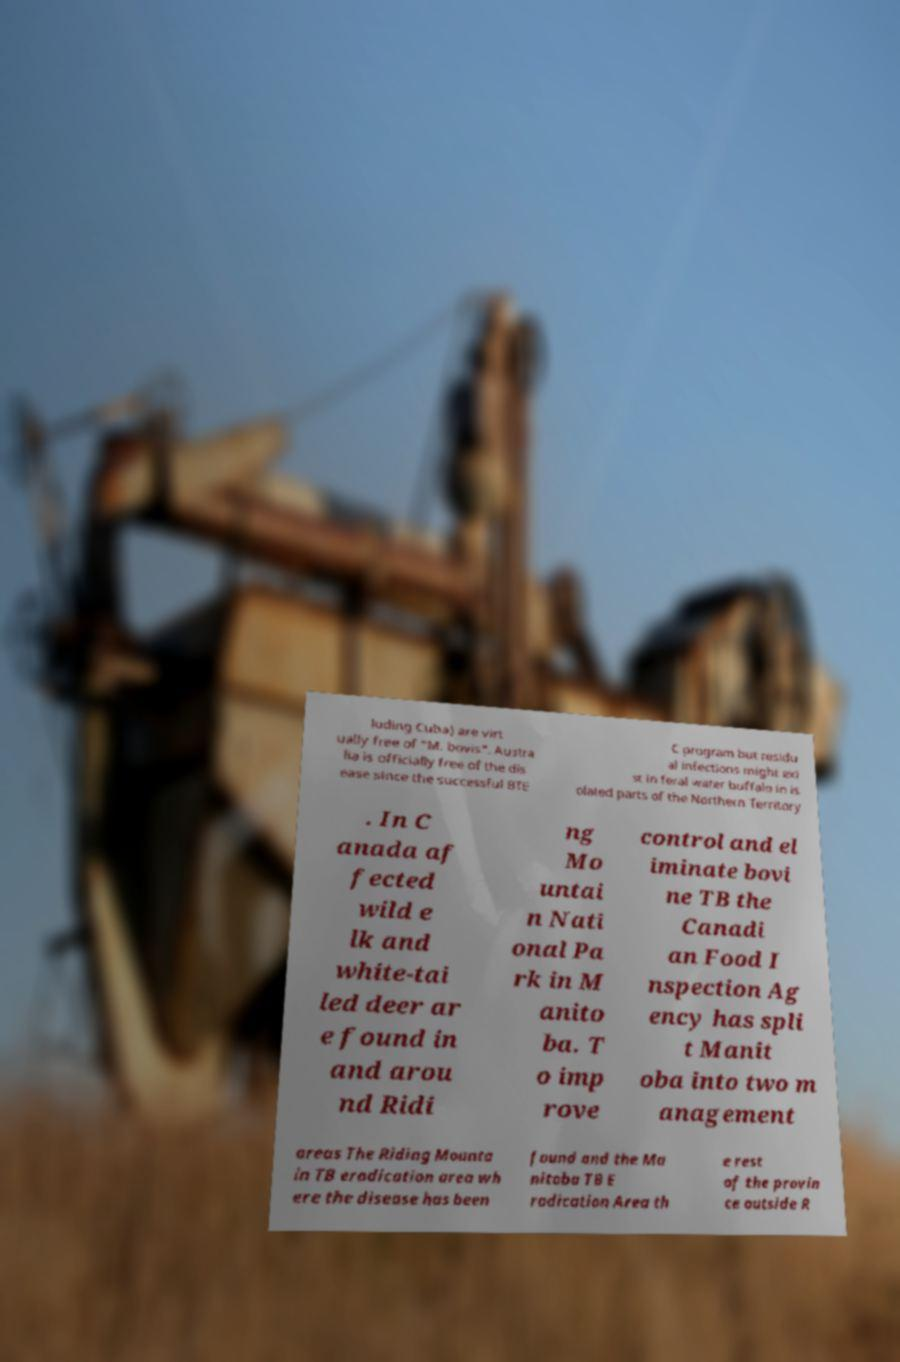Please read and relay the text visible in this image. What does it say? luding Cuba) are virt ually free of "M. bovis". Austra lia is officially free of the dis ease since the successful BTE C program but residu al infections might exi st in feral water buffalo in is olated parts of the Northern Territory . In C anada af fected wild e lk and white-tai led deer ar e found in and arou nd Ridi ng Mo untai n Nati onal Pa rk in M anito ba. T o imp rove control and el iminate bovi ne TB the Canadi an Food I nspection Ag ency has spli t Manit oba into two m anagement areas The Riding Mounta in TB eradication area wh ere the disease has been found and the Ma nitoba TB E radication Area th e rest of the provin ce outside R 